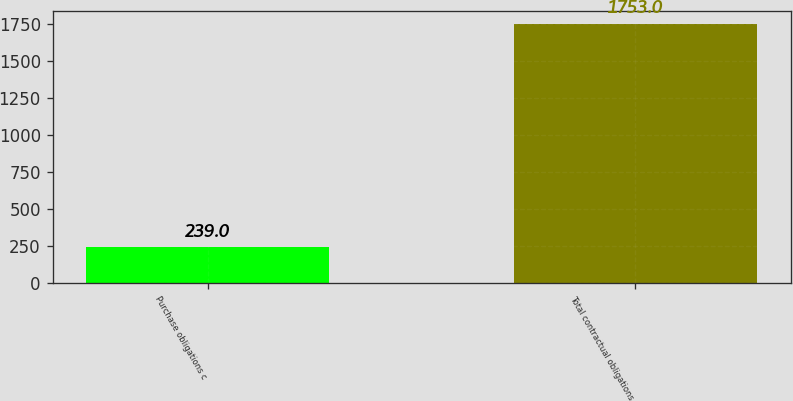Convert chart to OTSL. <chart><loc_0><loc_0><loc_500><loc_500><bar_chart><fcel>Purchase obligations c<fcel>Total contractual obligations<nl><fcel>239<fcel>1753<nl></chart> 